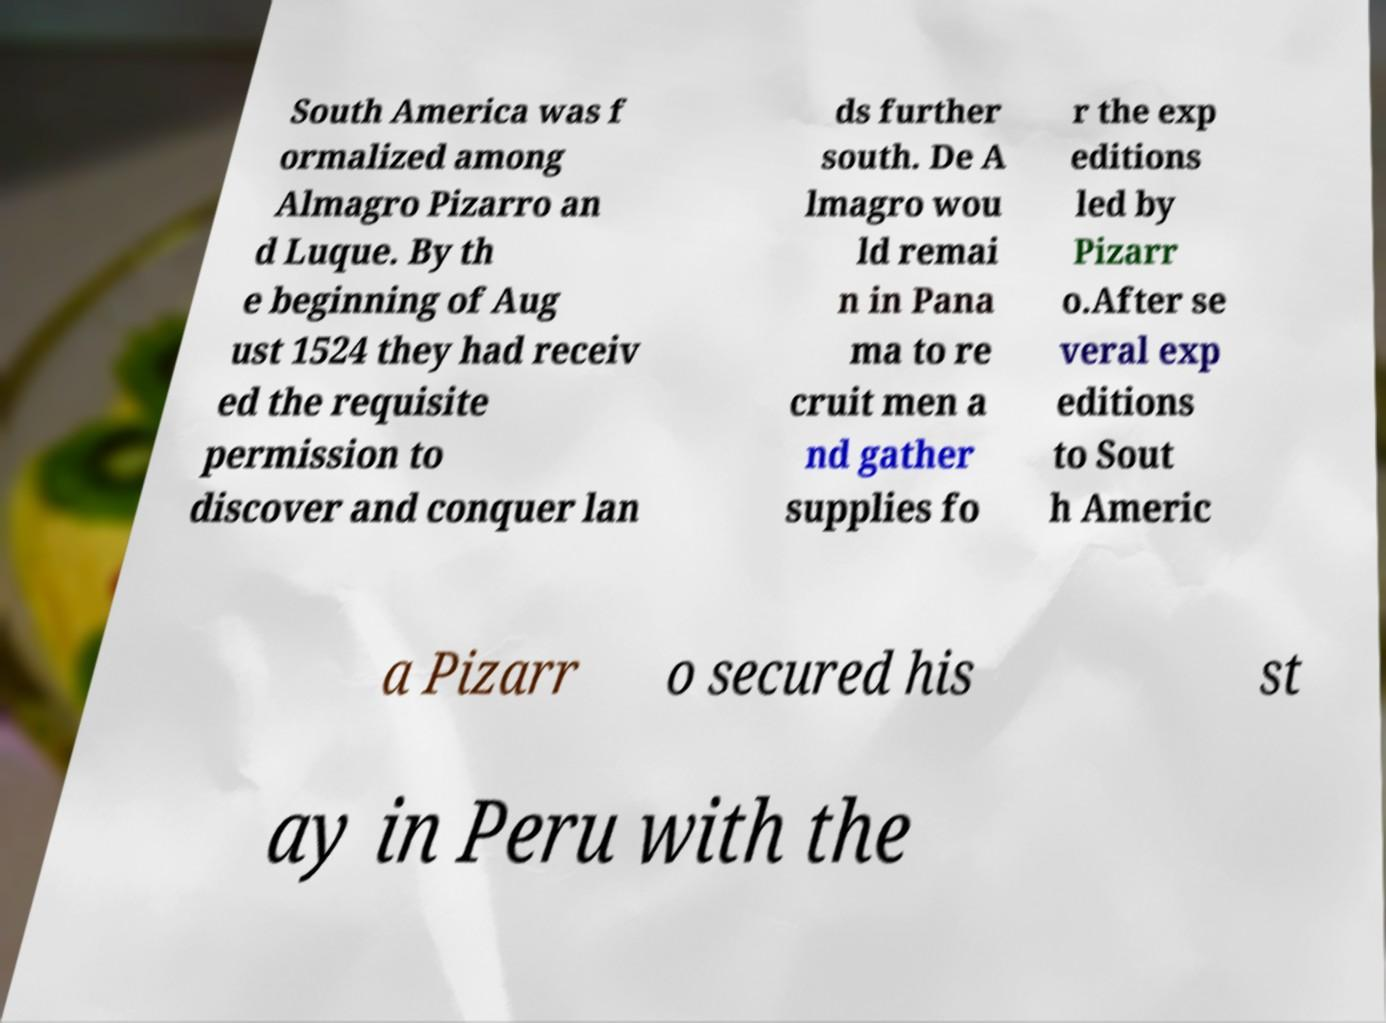Please read and relay the text visible in this image. What does it say? South America was f ormalized among Almagro Pizarro an d Luque. By th e beginning of Aug ust 1524 they had receiv ed the requisite permission to discover and conquer lan ds further south. De A lmagro wou ld remai n in Pana ma to re cruit men a nd gather supplies fo r the exp editions led by Pizarr o.After se veral exp editions to Sout h Americ a Pizarr o secured his st ay in Peru with the 